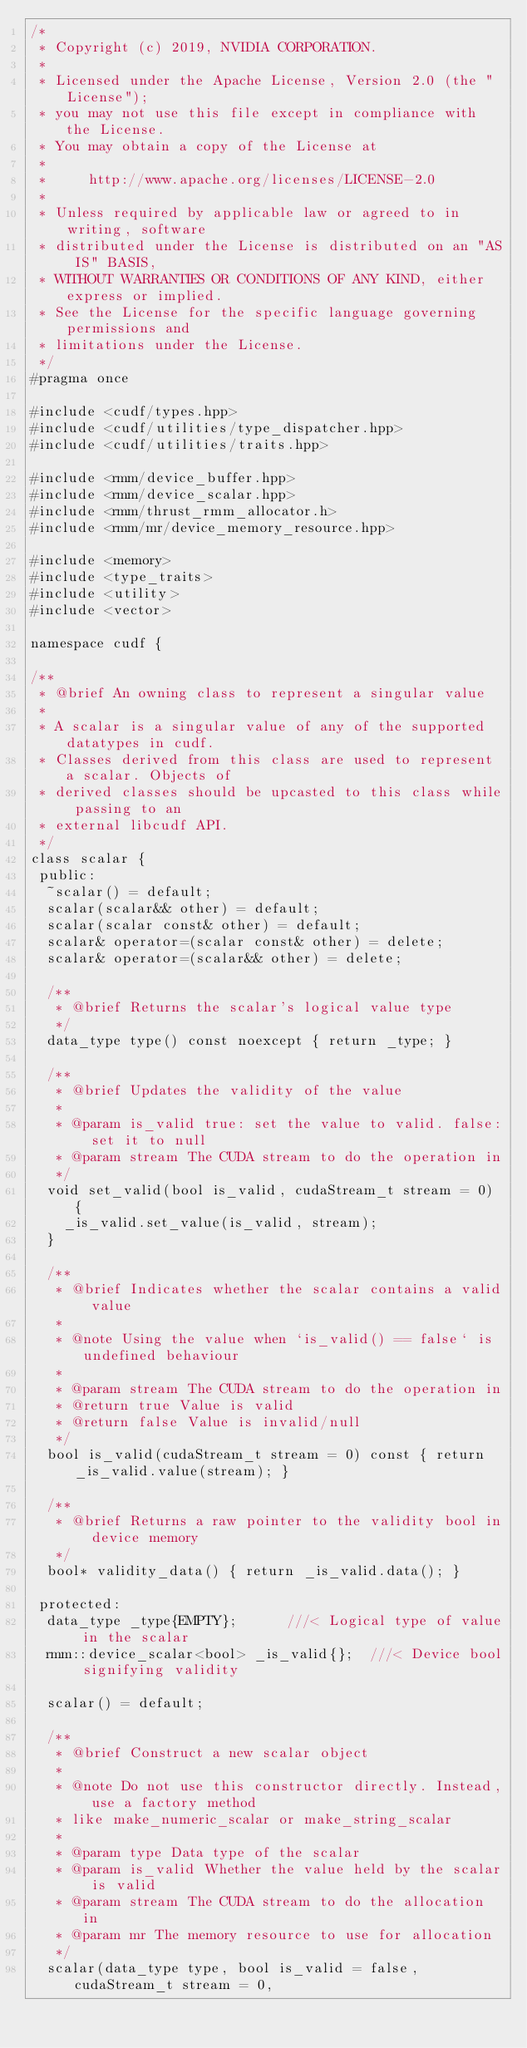Convert code to text. <code><loc_0><loc_0><loc_500><loc_500><_C++_>/*
 * Copyright (c) 2019, NVIDIA CORPORATION.
 *
 * Licensed under the Apache License, Version 2.0 (the "License");
 * you may not use this file except in compliance with the License.
 * You may obtain a copy of the License at
 *
 *     http://www.apache.org/licenses/LICENSE-2.0
 *
 * Unless required by applicable law or agreed to in writing, software
 * distributed under the License is distributed on an "AS IS" BASIS,
 * WITHOUT WARRANTIES OR CONDITIONS OF ANY KIND, either express or implied.
 * See the License for the specific language governing permissions and
 * limitations under the License.
 */
#pragma once

#include <cudf/types.hpp>
#include <cudf/utilities/type_dispatcher.hpp>
#include <cudf/utilities/traits.hpp>

#include <rmm/device_buffer.hpp>
#include <rmm/device_scalar.hpp>
#include <rmm/thrust_rmm_allocator.h>
#include <rmm/mr/device_memory_resource.hpp>

#include <memory>
#include <type_traits>
#include <utility>
#include <vector>

namespace cudf {

/**
 * @brief An owning class to represent a singular value
 * 
 * A scalar is a singular value of any of the supported datatypes in cudf. 
 * Classes derived from this class are used to represent a scalar. Objects of
 * derived classes should be upcasted to this class while passing to an
 * external libcudf API.
 */
class scalar {
 public:
  ~scalar() = default;
  scalar(scalar&& other) = default;
  scalar(scalar const& other) = default;
  scalar& operator=(scalar const& other) = delete;
  scalar& operator=(scalar&& other) = delete;
  
  /**
   * @brief Returns the scalar's logical value type
   */
  data_type type() const noexcept { return _type; }

  /**
   * @brief Updates the validity of the value
   * 
   * @param is_valid true: set the value to valid. false: set it to null
   * @param stream The CUDA stream to do the operation in
   */
  void set_valid(bool is_valid, cudaStream_t stream = 0) {
    _is_valid.set_value(is_valid, stream);
  }

  /**
   * @brief Indicates whether the scalar contains a valid value
   *
   * @note Using the value when `is_valid() == false` is undefined behaviour
   * 
   * @param stream The CUDA stream to do the operation in
   * @return true Value is valid
   * @return false Value is invalid/null
   */
  bool is_valid(cudaStream_t stream = 0) const { return _is_valid.value(stream); }

  /**
   * @brief Returns a raw pointer to the validity bool in device memory
   */
  bool* validity_data() { return _is_valid.data(); }

 protected:
  data_type _type{EMPTY};      ///< Logical type of value in the scalar
  rmm::device_scalar<bool> _is_valid{};  ///< Device bool signifying validity

  scalar() = default;

  /**
   * @brief Construct a new scalar object
   * 
   * @note Do not use this constructor directly. Instead, use a factory method
   * like make_numeric_scalar or make_string_scalar
   * 
   * @param type Data type of the scalar
   * @param is_valid Whether the value held by the scalar is valid
   * @param stream The CUDA stream to do the allocation in
   * @param mr The memory resource to use for allocation
   */
  scalar(data_type type, bool is_valid = false, cudaStream_t stream = 0,</code> 